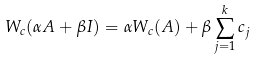<formula> <loc_0><loc_0><loc_500><loc_500>W _ { c } ( \alpha A + \beta I ) = \alpha W _ { c } ( A ) + \beta \sum _ { j = 1 } ^ { k } c _ { j }</formula> 